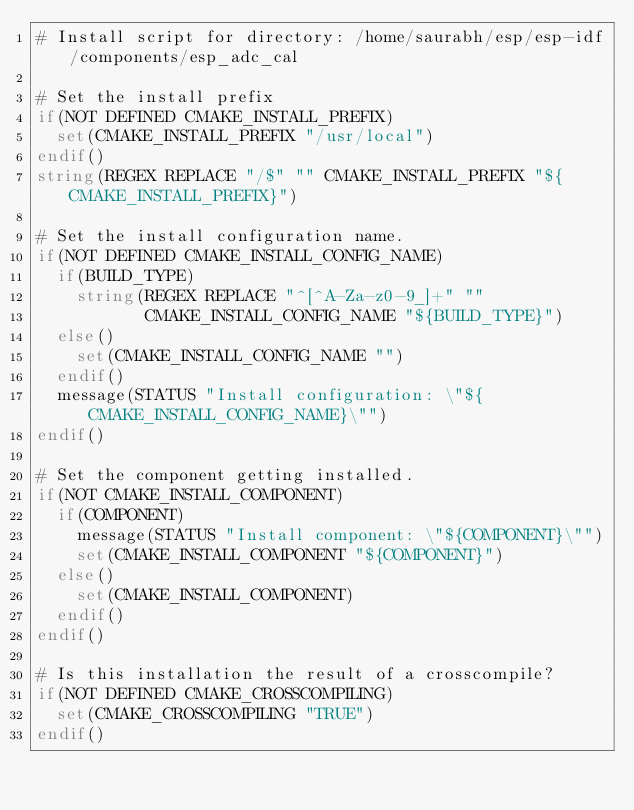<code> <loc_0><loc_0><loc_500><loc_500><_CMake_># Install script for directory: /home/saurabh/esp/esp-idf/components/esp_adc_cal

# Set the install prefix
if(NOT DEFINED CMAKE_INSTALL_PREFIX)
  set(CMAKE_INSTALL_PREFIX "/usr/local")
endif()
string(REGEX REPLACE "/$" "" CMAKE_INSTALL_PREFIX "${CMAKE_INSTALL_PREFIX}")

# Set the install configuration name.
if(NOT DEFINED CMAKE_INSTALL_CONFIG_NAME)
  if(BUILD_TYPE)
    string(REGEX REPLACE "^[^A-Za-z0-9_]+" ""
           CMAKE_INSTALL_CONFIG_NAME "${BUILD_TYPE}")
  else()
    set(CMAKE_INSTALL_CONFIG_NAME "")
  endif()
  message(STATUS "Install configuration: \"${CMAKE_INSTALL_CONFIG_NAME}\"")
endif()

# Set the component getting installed.
if(NOT CMAKE_INSTALL_COMPONENT)
  if(COMPONENT)
    message(STATUS "Install component: \"${COMPONENT}\"")
    set(CMAKE_INSTALL_COMPONENT "${COMPONENT}")
  else()
    set(CMAKE_INSTALL_COMPONENT)
  endif()
endif()

# Is this installation the result of a crosscompile?
if(NOT DEFINED CMAKE_CROSSCOMPILING)
  set(CMAKE_CROSSCOMPILING "TRUE")
endif()

</code> 